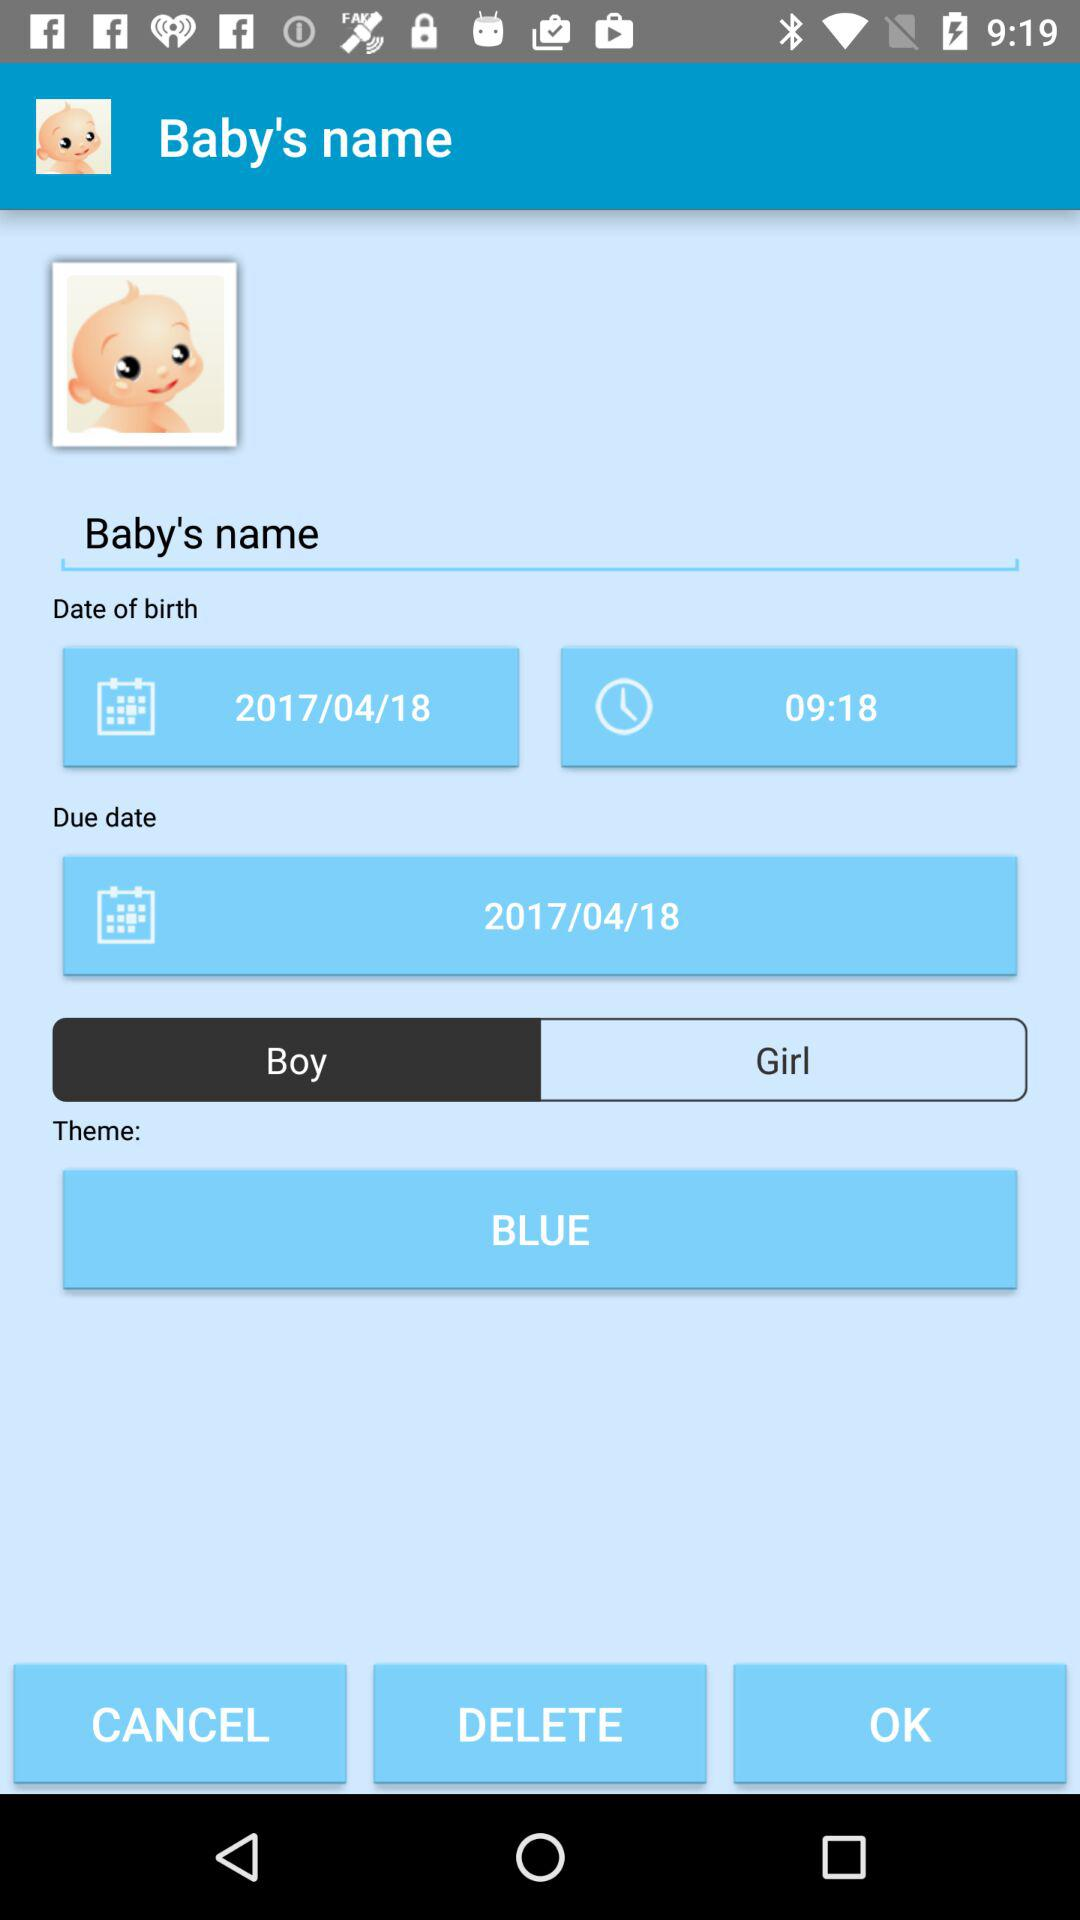What is the birth date and time? The birth date is April 18, 2017 and the time is 09:18. 